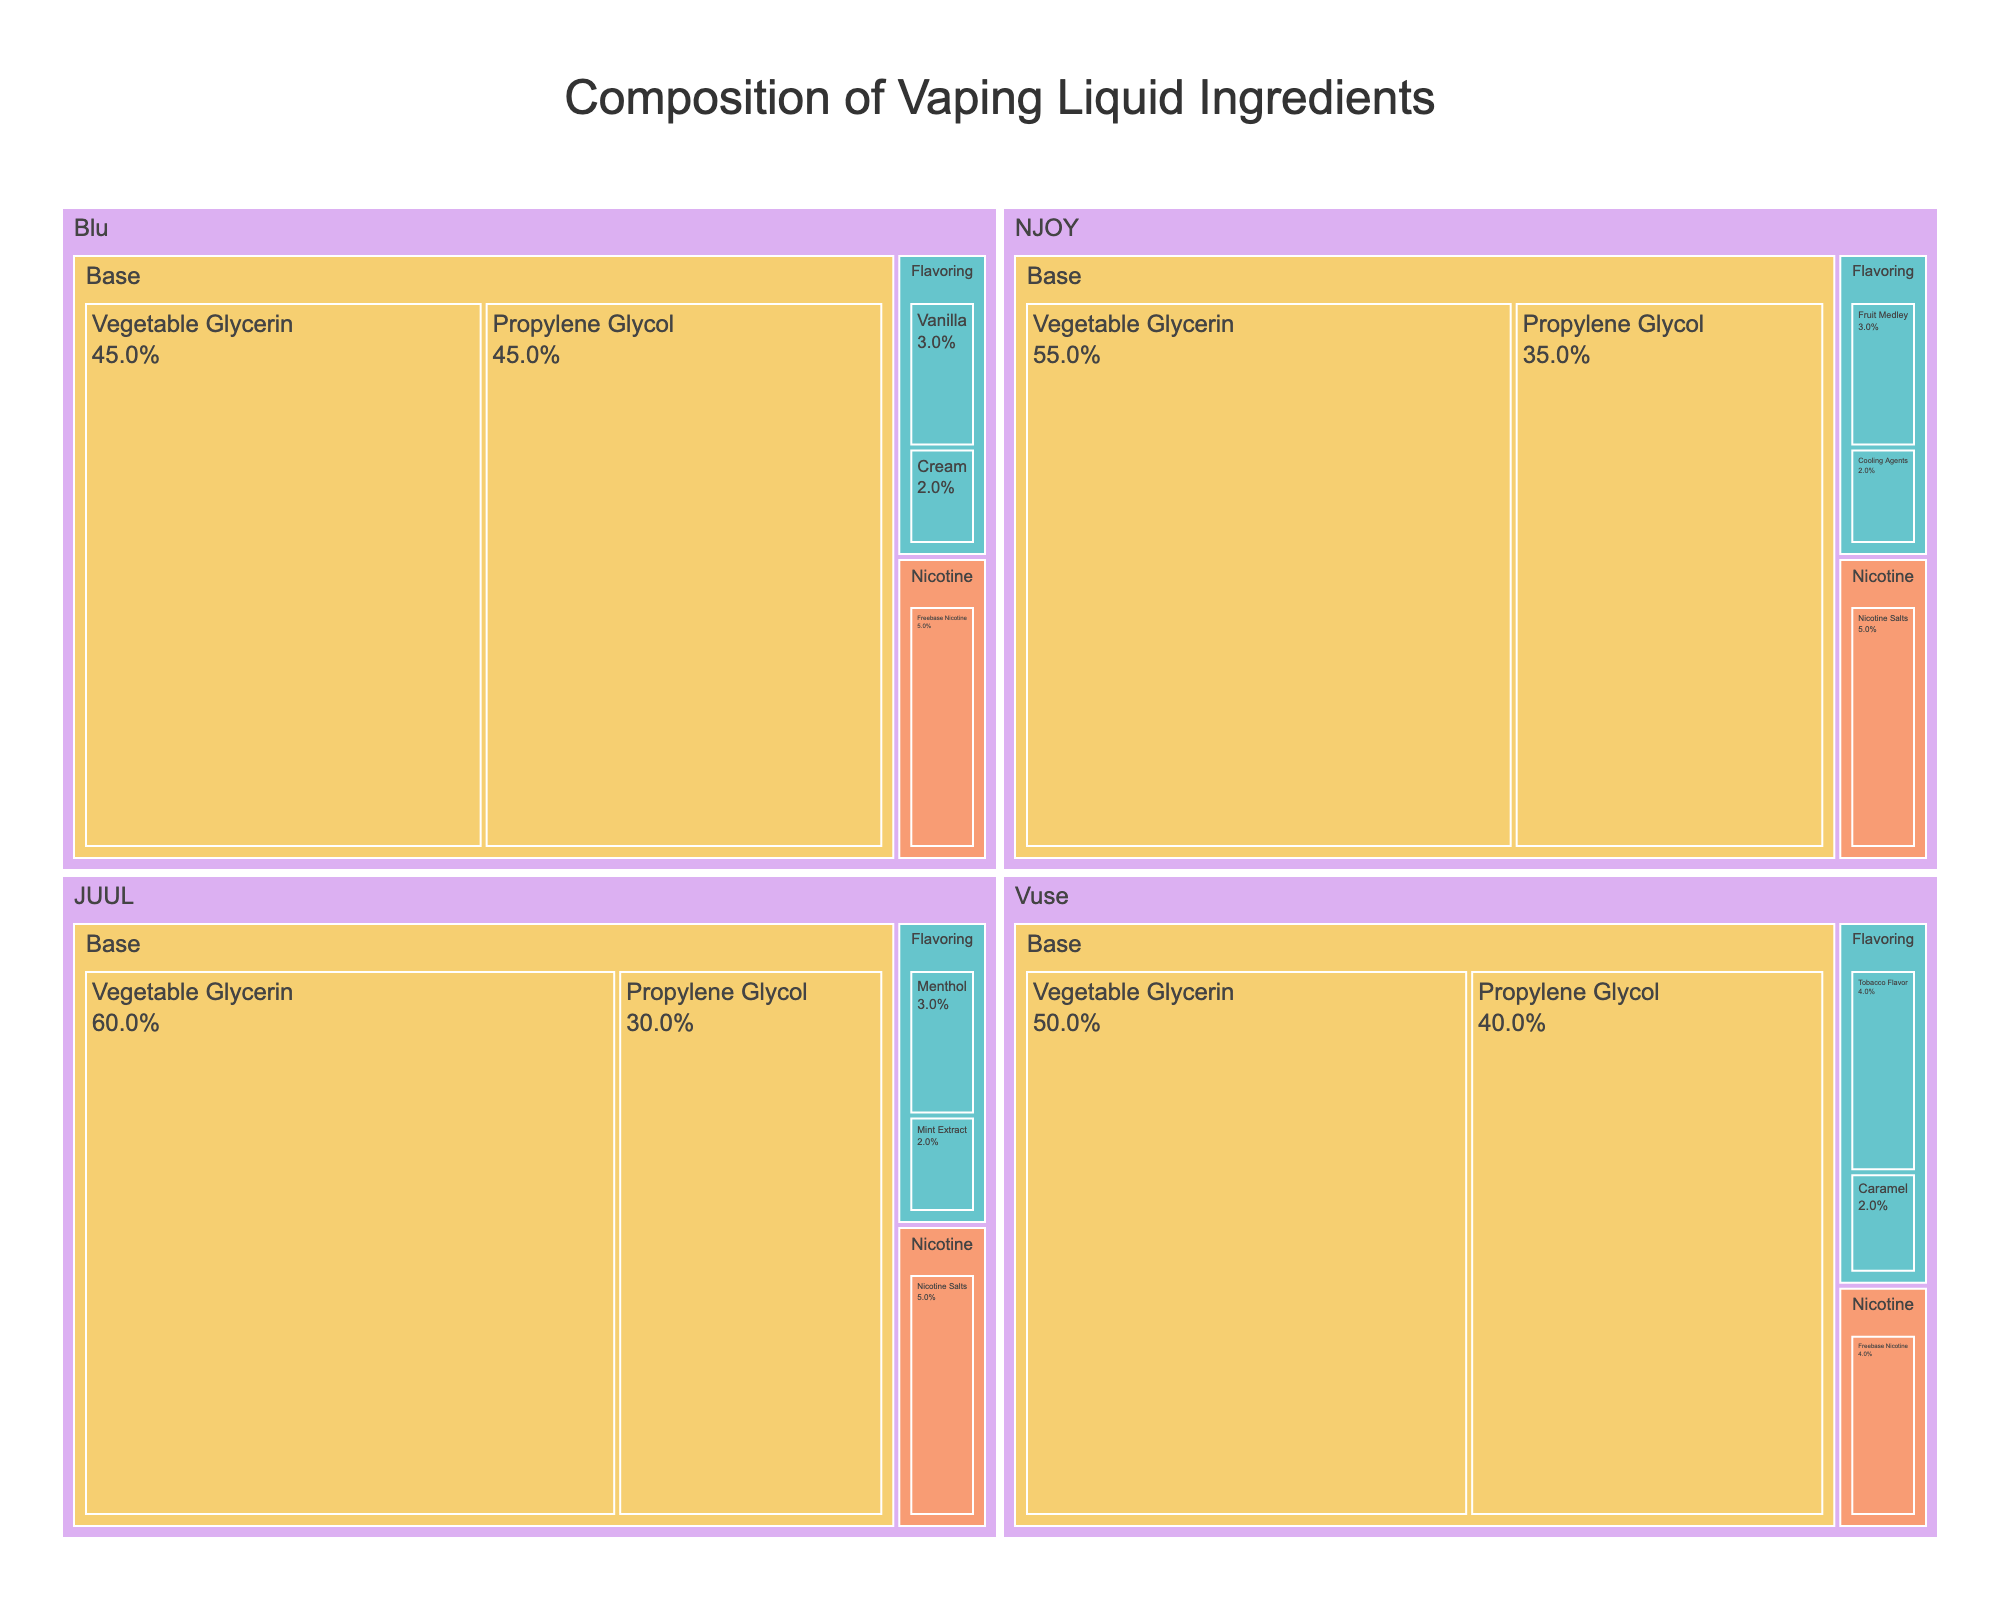How many brands of e-cigarettes are represented in the treemap? The treemap shows a breakdown of ingredients by brand, identifiable by the first level of subdivision. By counting the different sections at this level, you can see the number of brands.
Answer: 4 Which ingredient has the highest percentage for the brand JUUL? For JUUL, look at the subdivisions at the ingredient level within the JUUL section of the treemap. The largest subdivision in terms of area will have the highest percentage.
Answer: Vegetable Glycerin Which brand uses freebase nicotine and what are their respective percentages? Look within the Nicotine category for the specific brands using freebase nicotine. Each subdivision will indicate the percentage used by each brand.
Answer: Vuse (4%) and Blu (5%) Compare the base ingredient composition between JUUL and Vuse. Which brand has a higher percentage of Propylene Glycol? Look at the Base category for each brand and compare the subdivisions for Propylene Glycol. The brand with the larger area represents the higher percentage.
Answer: Vuse Calculate the total percentage of flavoring ingredients for the brand Blu. Identify all subdivisions under the Flavoring category for Blu, sum the percentages of all these flavoring ingredients to get the total.
Answer: 5% Which brand has the smallest percentage of Nicotine Salts, and what is that percentage? Examine the Nicotine category and identify the subdivisions for Nicotine Salts across all brands, then find the smallest area.
Answer: NJOY and JUUL (each 5%) Compare the overall composition of the Base category between NJOY and Blu. Which brand dedicates a larger percentage to their base ingredients? Sum the percentages of Propylene Glycol and Vegetable Glycerin for both NJOY and Blu, and compare the totals.
Answer: NJOY (90%) and Blu (90%) - Tie What is the combined total percentage of Vegetable Glycerin used by all four brands? Sum the percentages of Vegetable Glycerin across all sections for the four brands.
Answer: 210% Among the brands, which one uses the highest percentage of Menthol in their flavoring? Examine the Flavoring categories and find the brand with the subdivision representing Menthol. Compare these percentages to identify the highest one.
Answer: JUUL What is the proportion of Nicotine Salts used by NJOY compared to the total ingredients for that brand? The percentage of Nicotine Salts for NJOY is given as a part of the total 100%. It can be directly compared to 100% for proportion calculation.
Answer: 5% 